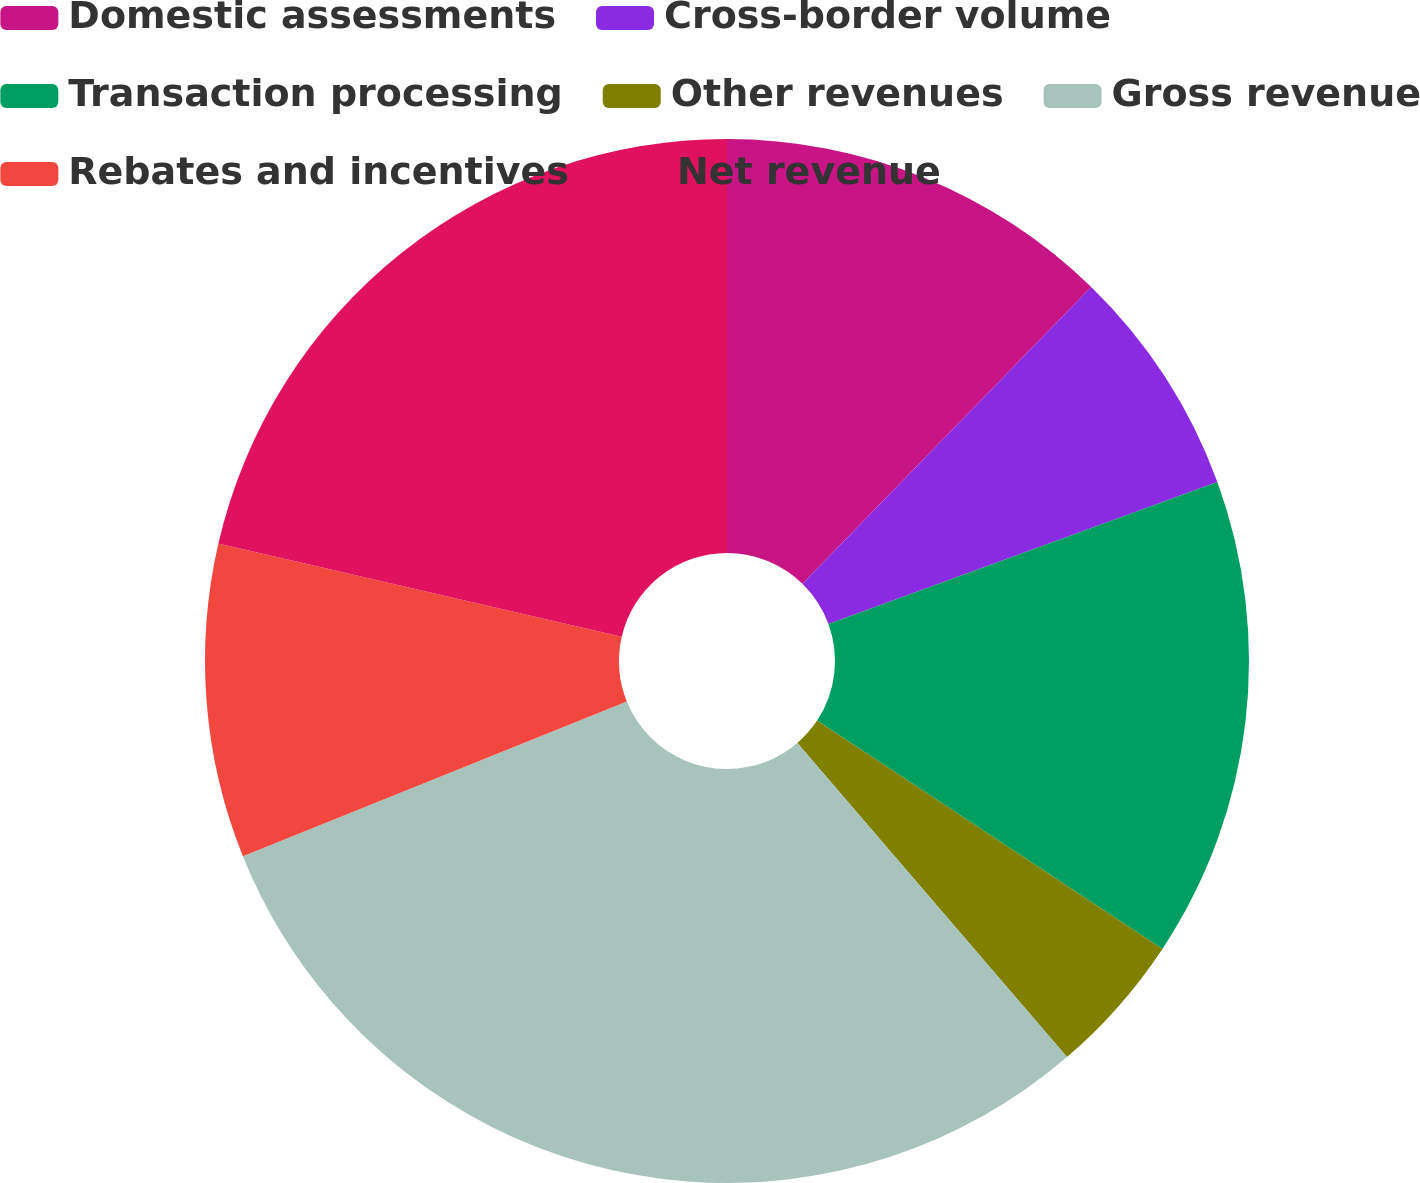<chart> <loc_0><loc_0><loc_500><loc_500><pie_chart><fcel>Domestic assessments<fcel>Cross-border volume<fcel>Transaction processing<fcel>Other revenues<fcel>Gross revenue<fcel>Rebates and incentives<fcel>Net revenue<nl><fcel>12.29%<fcel>7.14%<fcel>14.87%<fcel>4.41%<fcel>30.19%<fcel>9.71%<fcel>21.39%<nl></chart> 